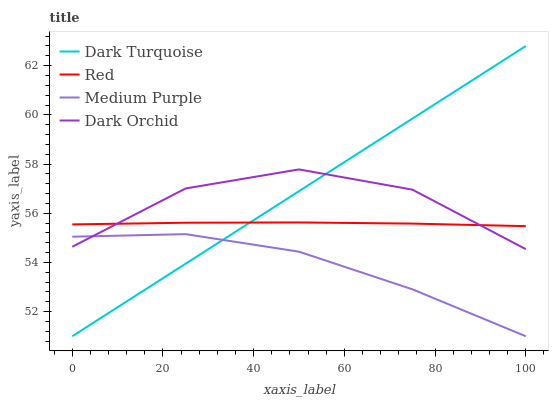Does Medium Purple have the minimum area under the curve?
Answer yes or no. Yes. Does Dark Turquoise have the maximum area under the curve?
Answer yes or no. Yes. Does Dark Orchid have the minimum area under the curve?
Answer yes or no. No. Does Dark Orchid have the maximum area under the curve?
Answer yes or no. No. Is Dark Turquoise the smoothest?
Answer yes or no. Yes. Is Dark Orchid the roughest?
Answer yes or no. Yes. Is Dark Orchid the smoothest?
Answer yes or no. No. Is Dark Turquoise the roughest?
Answer yes or no. No. Does Medium Purple have the lowest value?
Answer yes or no. Yes. Does Dark Orchid have the lowest value?
Answer yes or no. No. Does Dark Turquoise have the highest value?
Answer yes or no. Yes. Does Dark Orchid have the highest value?
Answer yes or no. No. Is Medium Purple less than Red?
Answer yes or no. Yes. Is Red greater than Medium Purple?
Answer yes or no. Yes. Does Red intersect Dark Orchid?
Answer yes or no. Yes. Is Red less than Dark Orchid?
Answer yes or no. No. Is Red greater than Dark Orchid?
Answer yes or no. No. Does Medium Purple intersect Red?
Answer yes or no. No. 